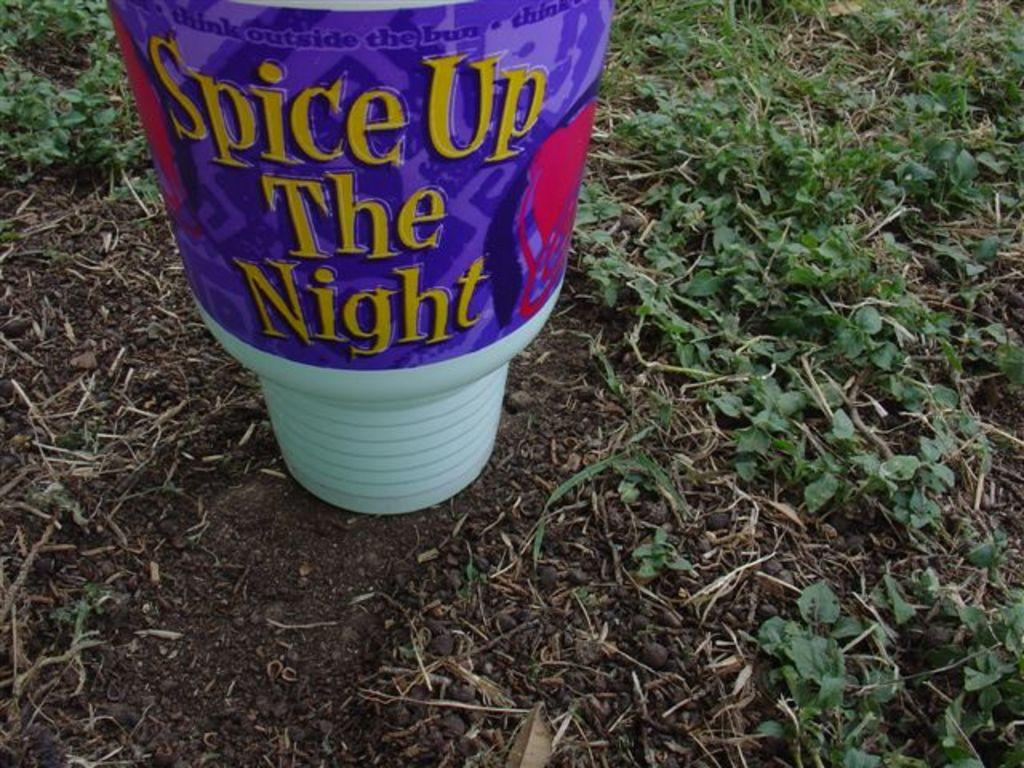What is the main object in the center of the image? There is a pot in the center of the image. What can be found at the bottom of the image? There are plants and soil at the bottom of the image. How many horses are visible in the image? There are no horses present in the image. Is there a camp set up in the image? There is no camp present in the image. 